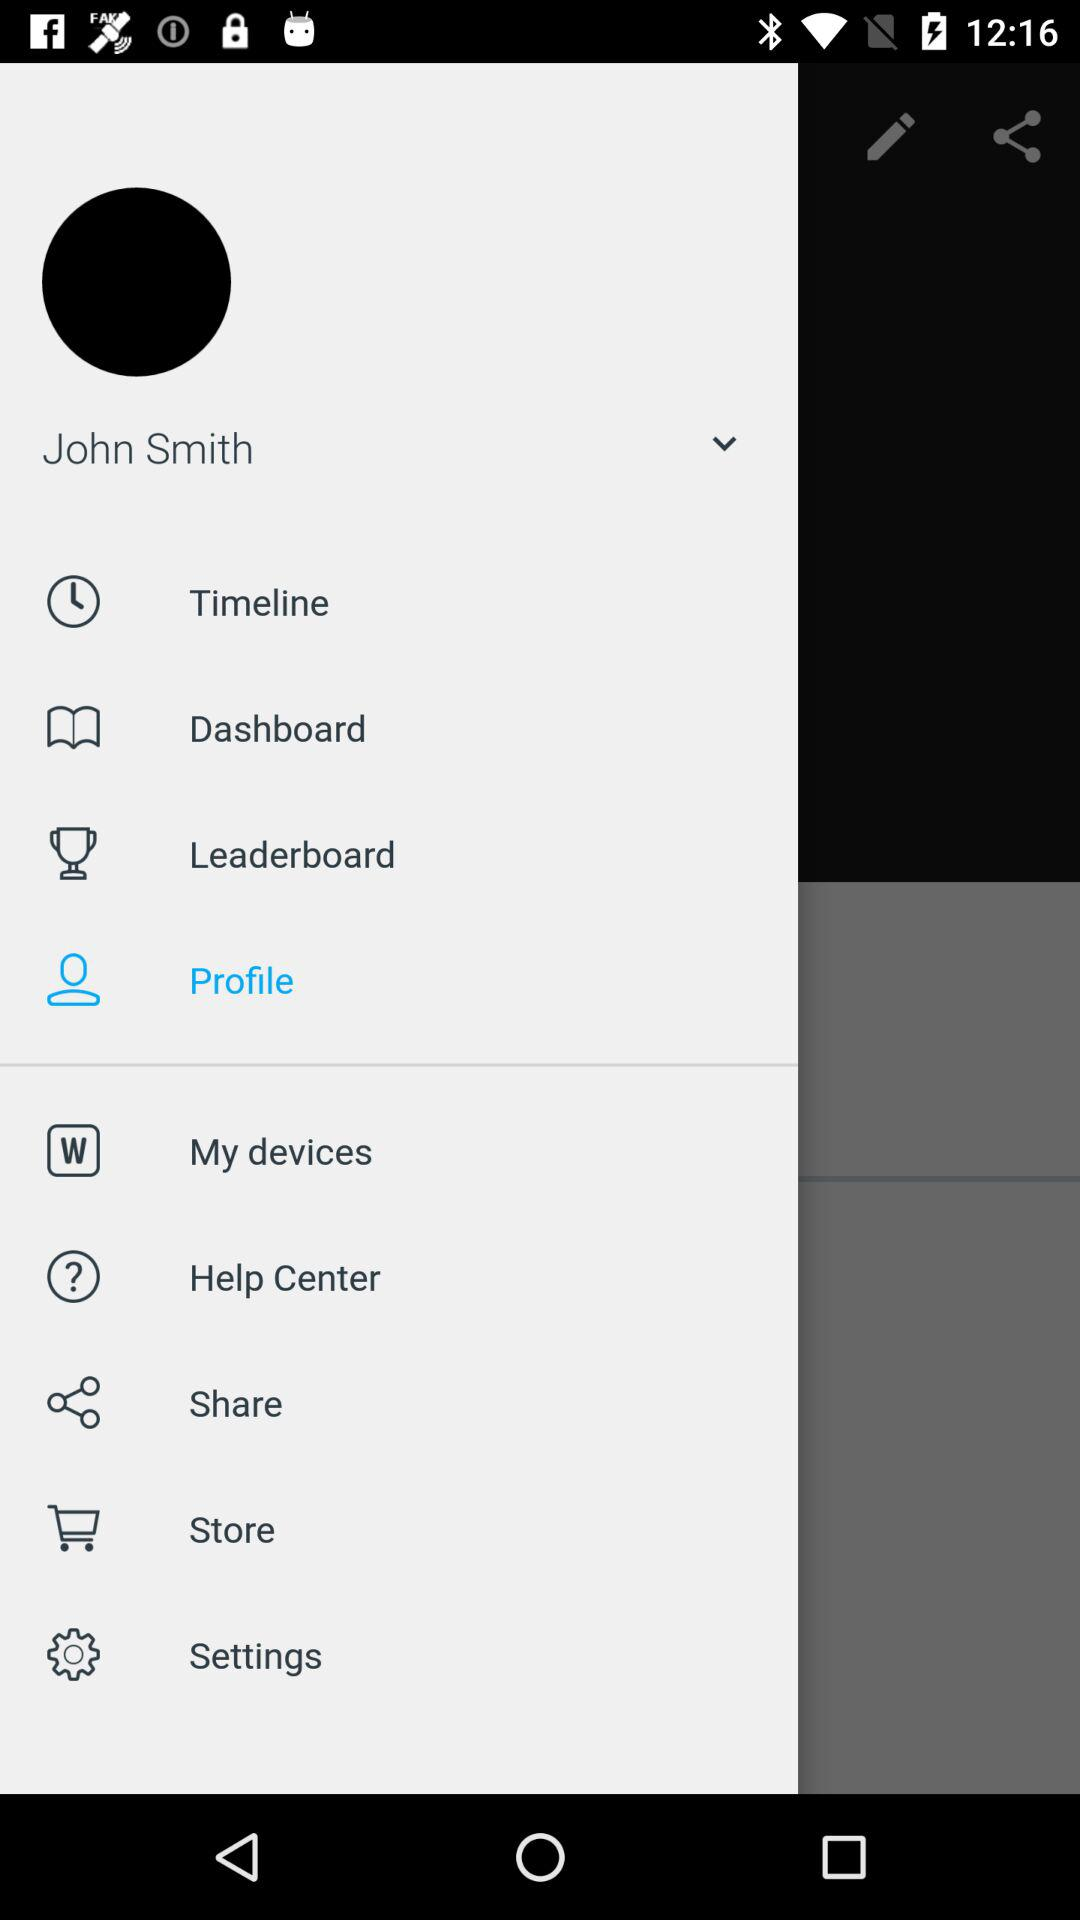What is the user name? The user name is "John Smith". 